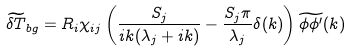<formula> <loc_0><loc_0><loc_500><loc_500>\widetilde { \delta T } _ { b g } = R _ { i } \chi _ { i j } \left ( \frac { S _ { j } } { i k ( \lambda _ { j } + i k ) } - \frac { S _ { j } \pi } { \lambda _ { j } } \delta ( k ) \right ) \widetilde { \phi \phi ^ { \prime } } ( k )</formula> 